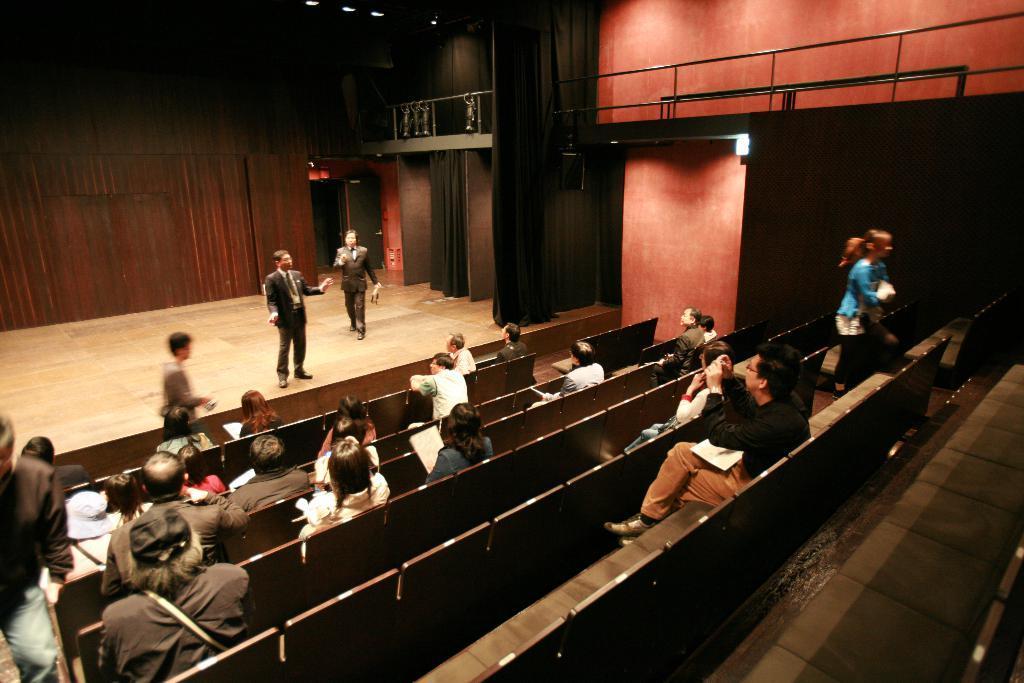In one or two sentences, can you explain what this image depicts? In the picture I can see people among them some are standing and some are sitting on chairs. In the background I can see fence, wall, lights on the ceiling, curtains and some other objects. 